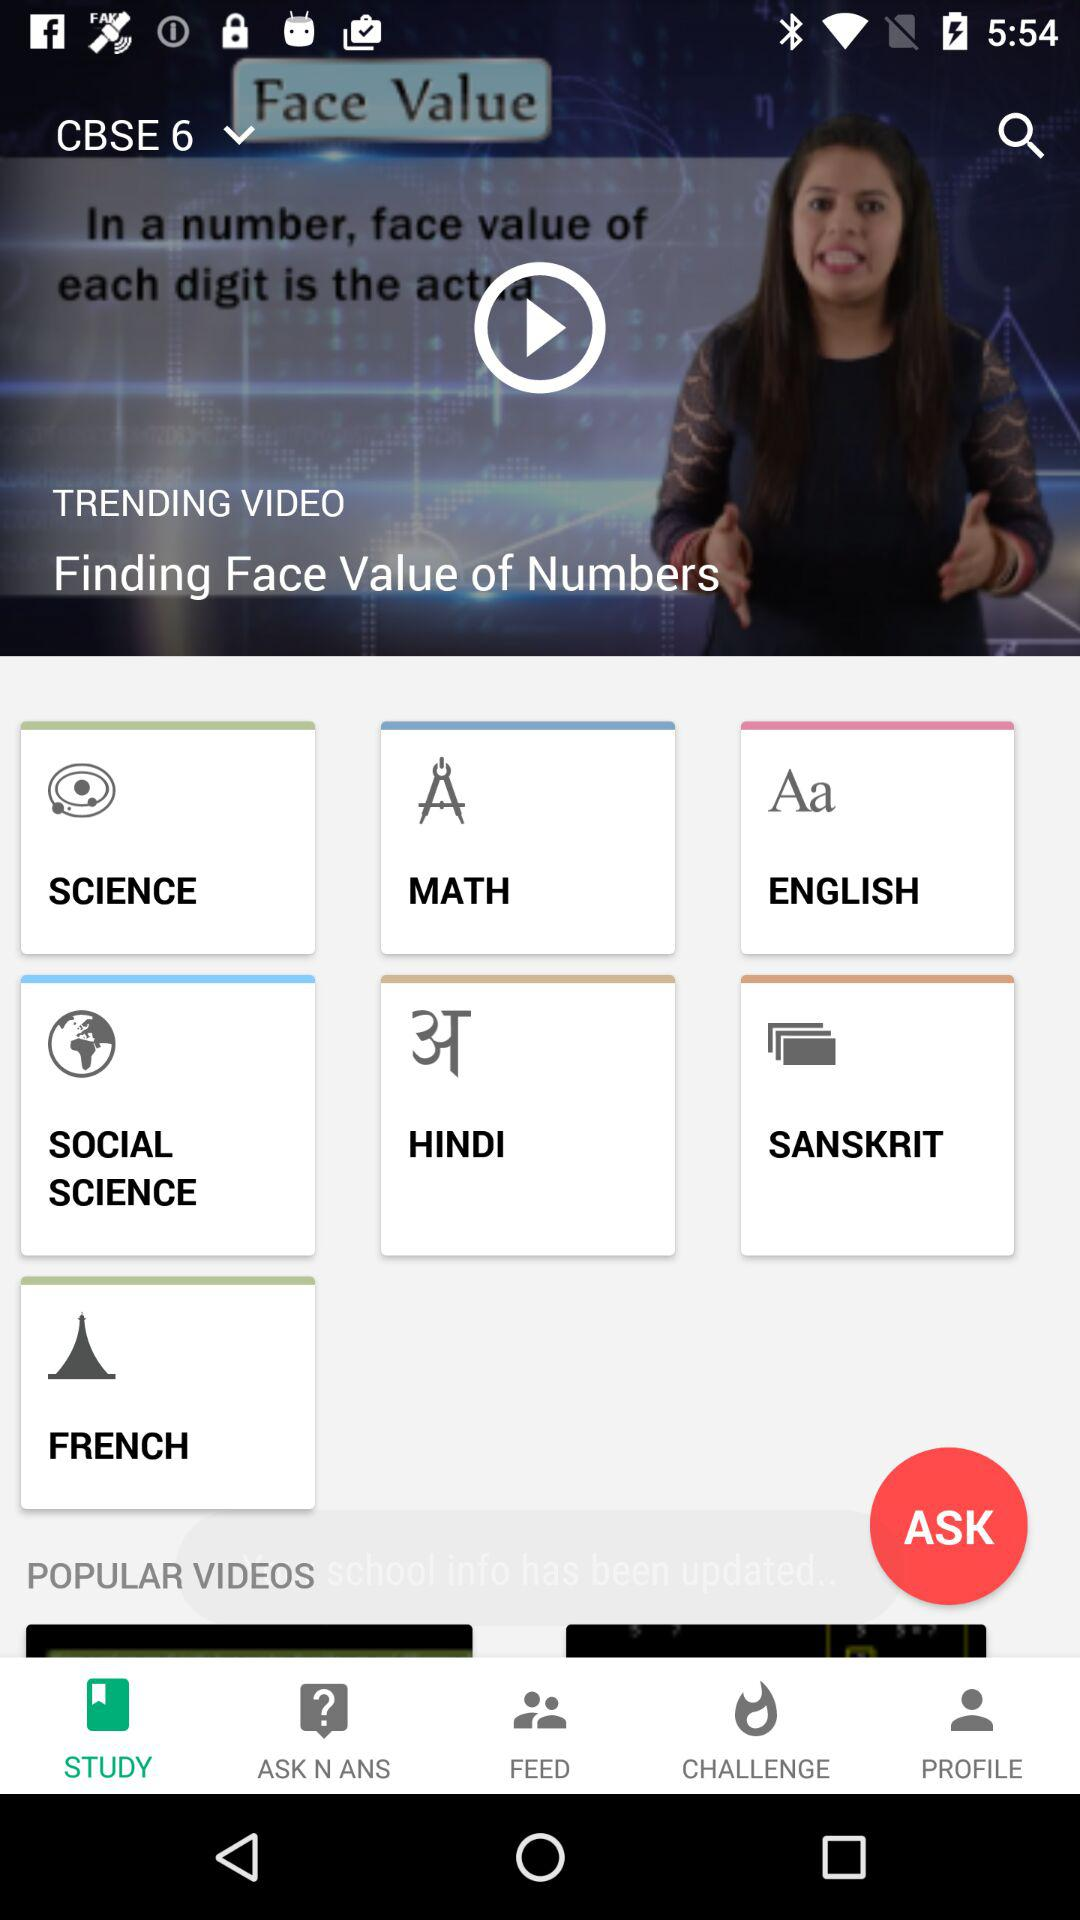Which class is the video for? The video is for 6th class of CBSE. 